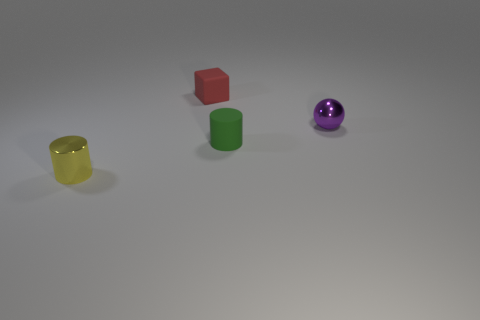Add 1 tiny green rubber cylinders. How many objects exist? 5 Subtract all blocks. How many objects are left? 3 Add 1 red matte blocks. How many red matte blocks are left? 2 Add 4 balls. How many balls exist? 5 Subtract 1 green cylinders. How many objects are left? 3 Subtract all purple metallic things. Subtract all small yellow objects. How many objects are left? 2 